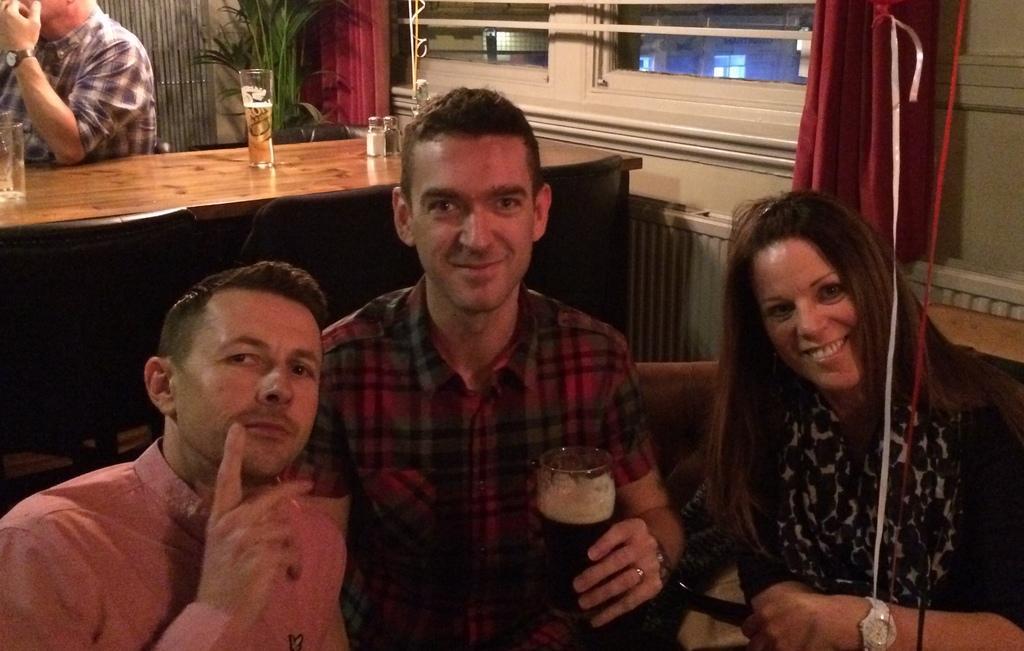How would you summarize this image in a sentence or two? This picture is of inside the room. On the right there is a woman smiling and sitting on the couch. In the center there is a man wearing red color shirt, holding a glass of drink, smiling and sitting on the couch. On the left there is a man sitting on the couch. In the background there is a table on the top of which a glass of drink and bottles are placed. There is a man seems to be sitting on the chair and we can see the windows, curtains and a houseplant. 